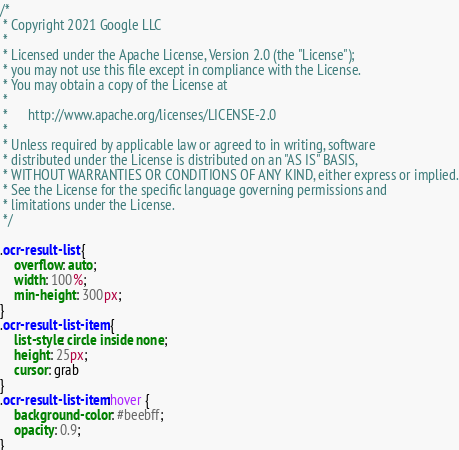Convert code to text. <code><loc_0><loc_0><loc_500><loc_500><_CSS_>/*
 * Copyright 2021 Google LLC
 *
 * Licensed under the Apache License, Version 2.0 (the "License");
 * you may not use this file except in compliance with the License.
 * You may obtain a copy of the License at
 *
 *      http://www.apache.org/licenses/LICENSE-2.0
 *
 * Unless required by applicable law or agreed to in writing, software
 * distributed under the License is distributed on an "AS IS" BASIS,
 * WITHOUT WARRANTIES OR CONDITIONS OF ANY KIND, either express or implied.
 * See the License for the specific language governing permissions and
 * limitations under the License.
 */

.ocr-result-list {
    overflow: auto;
    width: 100%;
    min-height: 300px;
}
.ocr-result-list-item {
    list-style: circle inside none;
    height: 25px;
    cursor: grab
}
.ocr-result-list-item:hover {
    background-color: #beebff;
    opacity: 0.9;
}</code> 